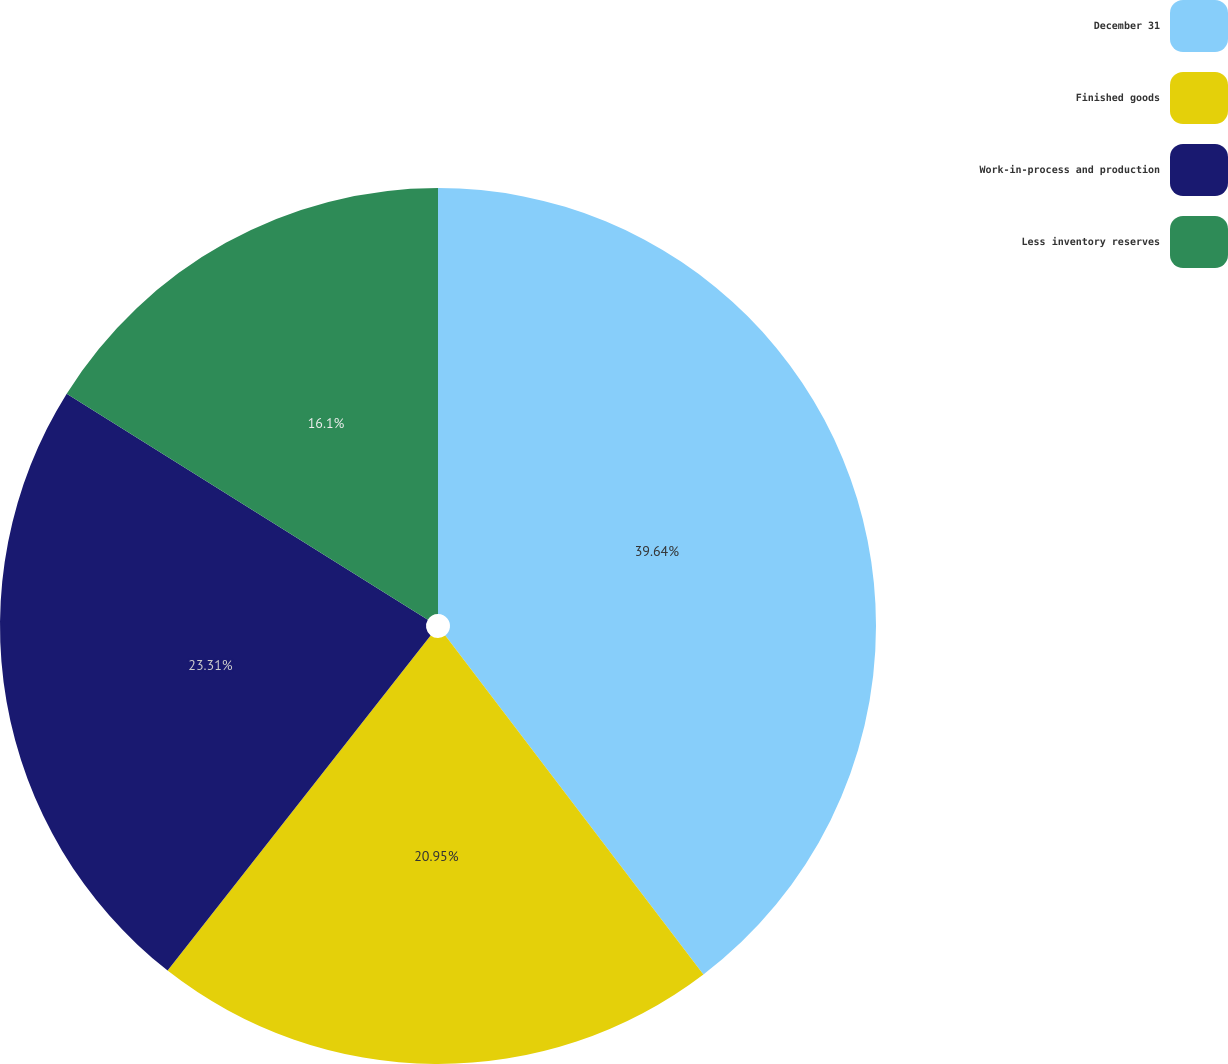<chart> <loc_0><loc_0><loc_500><loc_500><pie_chart><fcel>December 31<fcel>Finished goods<fcel>Work-in-process and production<fcel>Less inventory reserves<nl><fcel>39.64%<fcel>20.95%<fcel>23.31%<fcel>16.1%<nl></chart> 